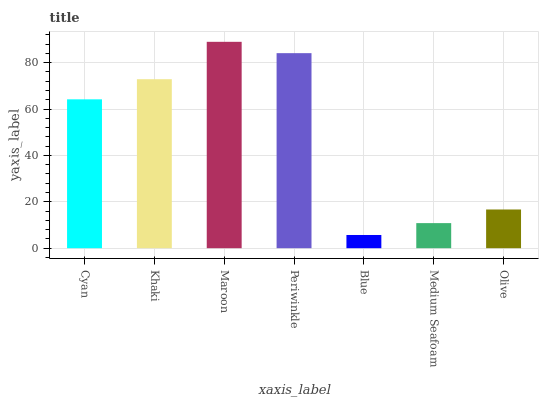Is Maroon the maximum?
Answer yes or no. Yes. Is Khaki the minimum?
Answer yes or no. No. Is Khaki the maximum?
Answer yes or no. No. Is Khaki greater than Cyan?
Answer yes or no. Yes. Is Cyan less than Khaki?
Answer yes or no. Yes. Is Cyan greater than Khaki?
Answer yes or no. No. Is Khaki less than Cyan?
Answer yes or no. No. Is Cyan the high median?
Answer yes or no. Yes. Is Cyan the low median?
Answer yes or no. Yes. Is Medium Seafoam the high median?
Answer yes or no. No. Is Maroon the low median?
Answer yes or no. No. 